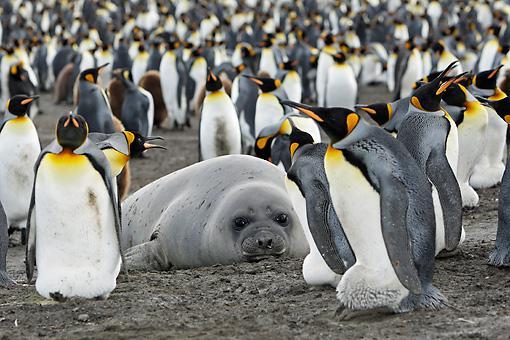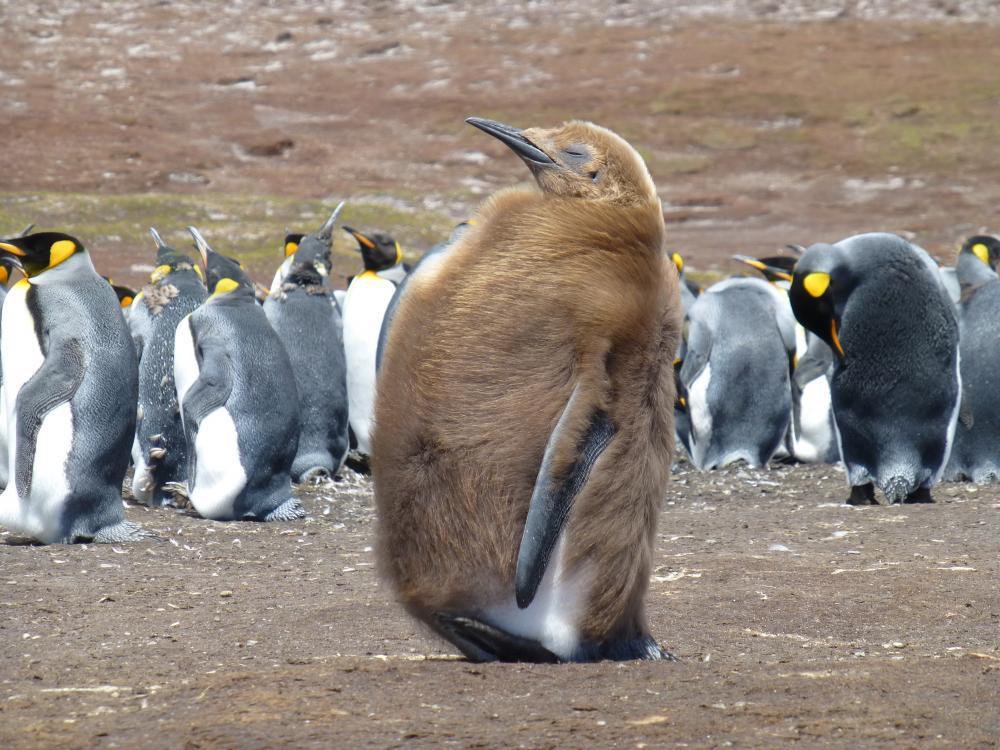The first image is the image on the left, the second image is the image on the right. Examine the images to the left and right. Is the description "There is one seal on the ground in one of the images." accurate? Answer yes or no. Yes. The first image is the image on the left, the second image is the image on the right. Examine the images to the left and right. Is the description "The ocean is visible." accurate? Answer yes or no. No. 